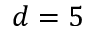<formula> <loc_0><loc_0><loc_500><loc_500>d = 5</formula> 